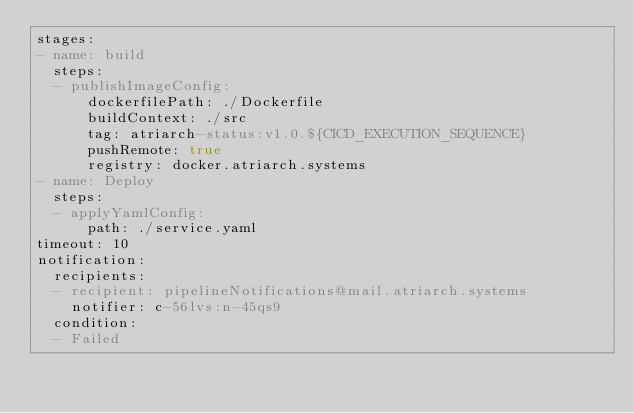<code> <loc_0><loc_0><loc_500><loc_500><_YAML_>stages:
- name: build
  steps:
  - publishImageConfig:
      dockerfilePath: ./Dockerfile
      buildContext: ./src
      tag: atriarch-status:v1.0.${CICD_EXECUTION_SEQUENCE}
      pushRemote: true
      registry: docker.atriarch.systems
- name: Deploy
  steps:
  - applyYamlConfig:
      path: ./service.yaml
timeout: 10
notification:
  recipients:
  - recipient: pipelineNotifications@mail.atriarch.systems
    notifier: c-56lvs:n-45qs9
  condition:
  - Failed
</code> 